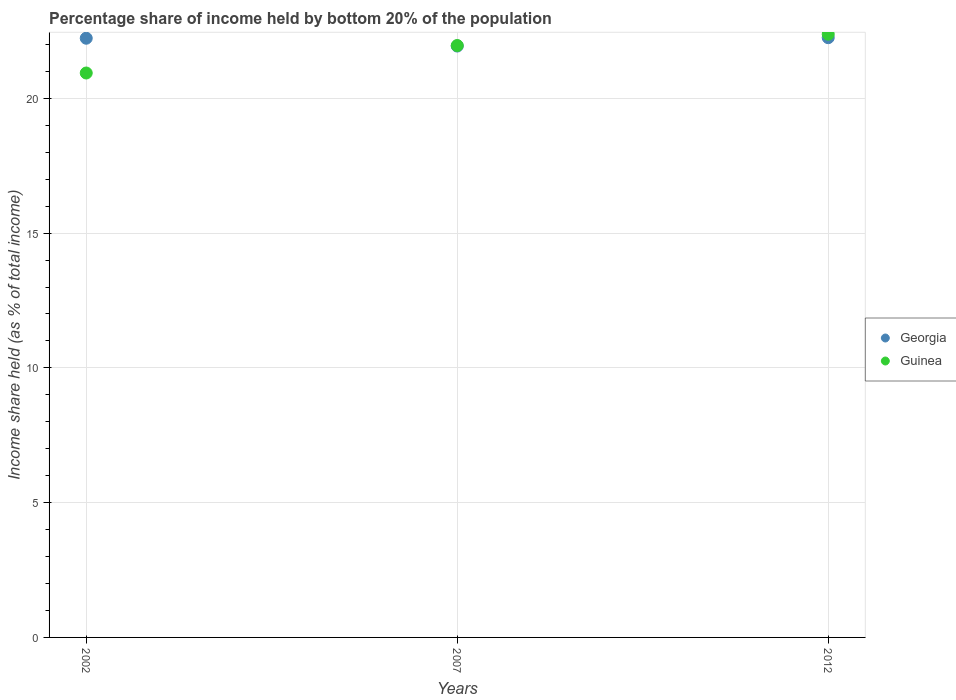What is the share of income held by bottom 20% of the population in Guinea in 2007?
Your answer should be compact. 21.96. Across all years, what is the maximum share of income held by bottom 20% of the population in Guinea?
Your answer should be compact. 22.38. Across all years, what is the minimum share of income held by bottom 20% of the population in Guinea?
Provide a succinct answer. 20.94. In which year was the share of income held by bottom 20% of the population in Georgia maximum?
Keep it short and to the point. 2012. In which year was the share of income held by bottom 20% of the population in Georgia minimum?
Provide a succinct answer. 2007. What is the total share of income held by bottom 20% of the population in Georgia in the graph?
Keep it short and to the point. 66.42. What is the difference between the share of income held by bottom 20% of the population in Georgia in 2002 and that in 2012?
Give a very brief answer. -0.02. What is the difference between the share of income held by bottom 20% of the population in Guinea in 2002 and the share of income held by bottom 20% of the population in Georgia in 2012?
Offer a very short reply. -1.31. What is the average share of income held by bottom 20% of the population in Georgia per year?
Offer a terse response. 22.14. In the year 2012, what is the difference between the share of income held by bottom 20% of the population in Georgia and share of income held by bottom 20% of the population in Guinea?
Your answer should be very brief. -0.13. What is the ratio of the share of income held by bottom 20% of the population in Guinea in 2002 to that in 2007?
Ensure brevity in your answer.  0.95. Is the share of income held by bottom 20% of the population in Georgia in 2002 less than that in 2012?
Your answer should be compact. Yes. Is the difference between the share of income held by bottom 20% of the population in Georgia in 2002 and 2007 greater than the difference between the share of income held by bottom 20% of the population in Guinea in 2002 and 2007?
Give a very brief answer. Yes. What is the difference between the highest and the second highest share of income held by bottom 20% of the population in Georgia?
Keep it short and to the point. 0.02. What is the difference between the highest and the lowest share of income held by bottom 20% of the population in Georgia?
Provide a short and direct response. 0.31. In how many years, is the share of income held by bottom 20% of the population in Georgia greater than the average share of income held by bottom 20% of the population in Georgia taken over all years?
Provide a short and direct response. 2. Is the share of income held by bottom 20% of the population in Guinea strictly greater than the share of income held by bottom 20% of the population in Georgia over the years?
Provide a short and direct response. No. Is the share of income held by bottom 20% of the population in Guinea strictly less than the share of income held by bottom 20% of the population in Georgia over the years?
Your response must be concise. No. Are the values on the major ticks of Y-axis written in scientific E-notation?
Make the answer very short. No. Does the graph contain grids?
Ensure brevity in your answer.  Yes. Where does the legend appear in the graph?
Offer a very short reply. Center right. How are the legend labels stacked?
Offer a terse response. Vertical. What is the title of the graph?
Offer a very short reply. Percentage share of income held by bottom 20% of the population. What is the label or title of the Y-axis?
Ensure brevity in your answer.  Income share held (as % of total income). What is the Income share held (as % of total income) of Georgia in 2002?
Offer a very short reply. 22.23. What is the Income share held (as % of total income) in Guinea in 2002?
Your response must be concise. 20.94. What is the Income share held (as % of total income) in Georgia in 2007?
Ensure brevity in your answer.  21.94. What is the Income share held (as % of total income) of Guinea in 2007?
Provide a short and direct response. 21.96. What is the Income share held (as % of total income) of Georgia in 2012?
Your response must be concise. 22.25. What is the Income share held (as % of total income) in Guinea in 2012?
Your response must be concise. 22.38. Across all years, what is the maximum Income share held (as % of total income) in Georgia?
Ensure brevity in your answer.  22.25. Across all years, what is the maximum Income share held (as % of total income) of Guinea?
Your answer should be compact. 22.38. Across all years, what is the minimum Income share held (as % of total income) of Georgia?
Provide a short and direct response. 21.94. Across all years, what is the minimum Income share held (as % of total income) of Guinea?
Make the answer very short. 20.94. What is the total Income share held (as % of total income) of Georgia in the graph?
Give a very brief answer. 66.42. What is the total Income share held (as % of total income) of Guinea in the graph?
Keep it short and to the point. 65.28. What is the difference between the Income share held (as % of total income) in Georgia in 2002 and that in 2007?
Provide a short and direct response. 0.29. What is the difference between the Income share held (as % of total income) in Guinea in 2002 and that in 2007?
Give a very brief answer. -1.02. What is the difference between the Income share held (as % of total income) in Georgia in 2002 and that in 2012?
Keep it short and to the point. -0.02. What is the difference between the Income share held (as % of total income) of Guinea in 2002 and that in 2012?
Offer a terse response. -1.44. What is the difference between the Income share held (as % of total income) in Georgia in 2007 and that in 2012?
Provide a succinct answer. -0.31. What is the difference between the Income share held (as % of total income) of Guinea in 2007 and that in 2012?
Keep it short and to the point. -0.42. What is the difference between the Income share held (as % of total income) of Georgia in 2002 and the Income share held (as % of total income) of Guinea in 2007?
Provide a succinct answer. 0.27. What is the difference between the Income share held (as % of total income) in Georgia in 2002 and the Income share held (as % of total income) in Guinea in 2012?
Keep it short and to the point. -0.15. What is the difference between the Income share held (as % of total income) in Georgia in 2007 and the Income share held (as % of total income) in Guinea in 2012?
Give a very brief answer. -0.44. What is the average Income share held (as % of total income) in Georgia per year?
Provide a short and direct response. 22.14. What is the average Income share held (as % of total income) of Guinea per year?
Provide a short and direct response. 21.76. In the year 2002, what is the difference between the Income share held (as % of total income) in Georgia and Income share held (as % of total income) in Guinea?
Keep it short and to the point. 1.29. In the year 2007, what is the difference between the Income share held (as % of total income) of Georgia and Income share held (as % of total income) of Guinea?
Offer a very short reply. -0.02. In the year 2012, what is the difference between the Income share held (as % of total income) in Georgia and Income share held (as % of total income) in Guinea?
Provide a succinct answer. -0.13. What is the ratio of the Income share held (as % of total income) of Georgia in 2002 to that in 2007?
Your response must be concise. 1.01. What is the ratio of the Income share held (as % of total income) in Guinea in 2002 to that in 2007?
Provide a succinct answer. 0.95. What is the ratio of the Income share held (as % of total income) in Guinea in 2002 to that in 2012?
Ensure brevity in your answer.  0.94. What is the ratio of the Income share held (as % of total income) in Georgia in 2007 to that in 2012?
Your answer should be compact. 0.99. What is the ratio of the Income share held (as % of total income) in Guinea in 2007 to that in 2012?
Make the answer very short. 0.98. What is the difference between the highest and the second highest Income share held (as % of total income) in Georgia?
Offer a very short reply. 0.02. What is the difference between the highest and the second highest Income share held (as % of total income) of Guinea?
Keep it short and to the point. 0.42. What is the difference between the highest and the lowest Income share held (as % of total income) in Georgia?
Your answer should be very brief. 0.31. What is the difference between the highest and the lowest Income share held (as % of total income) in Guinea?
Ensure brevity in your answer.  1.44. 